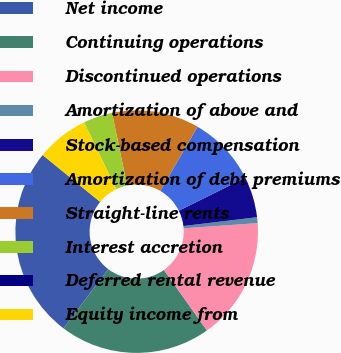<chart> <loc_0><loc_0><loc_500><loc_500><pie_chart><fcel>Net income<fcel>Continuing operations<fcel>Discontinued operations<fcel>Amortization of above and<fcel>Stock-based compensation<fcel>Amortization of debt premiums<fcel>Straight-line rents<fcel>Interest accretion<fcel>Deferred rental revenue<fcel>Equity income from<nl><fcel>25.58%<fcel>20.15%<fcel>16.28%<fcel>0.78%<fcel>5.43%<fcel>9.3%<fcel>11.63%<fcel>3.88%<fcel>0.0%<fcel>6.98%<nl></chart> 